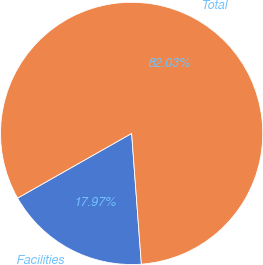Convert chart to OTSL. <chart><loc_0><loc_0><loc_500><loc_500><pie_chart><fcel>Facilities<fcel>Total<nl><fcel>17.97%<fcel>82.03%<nl></chart> 